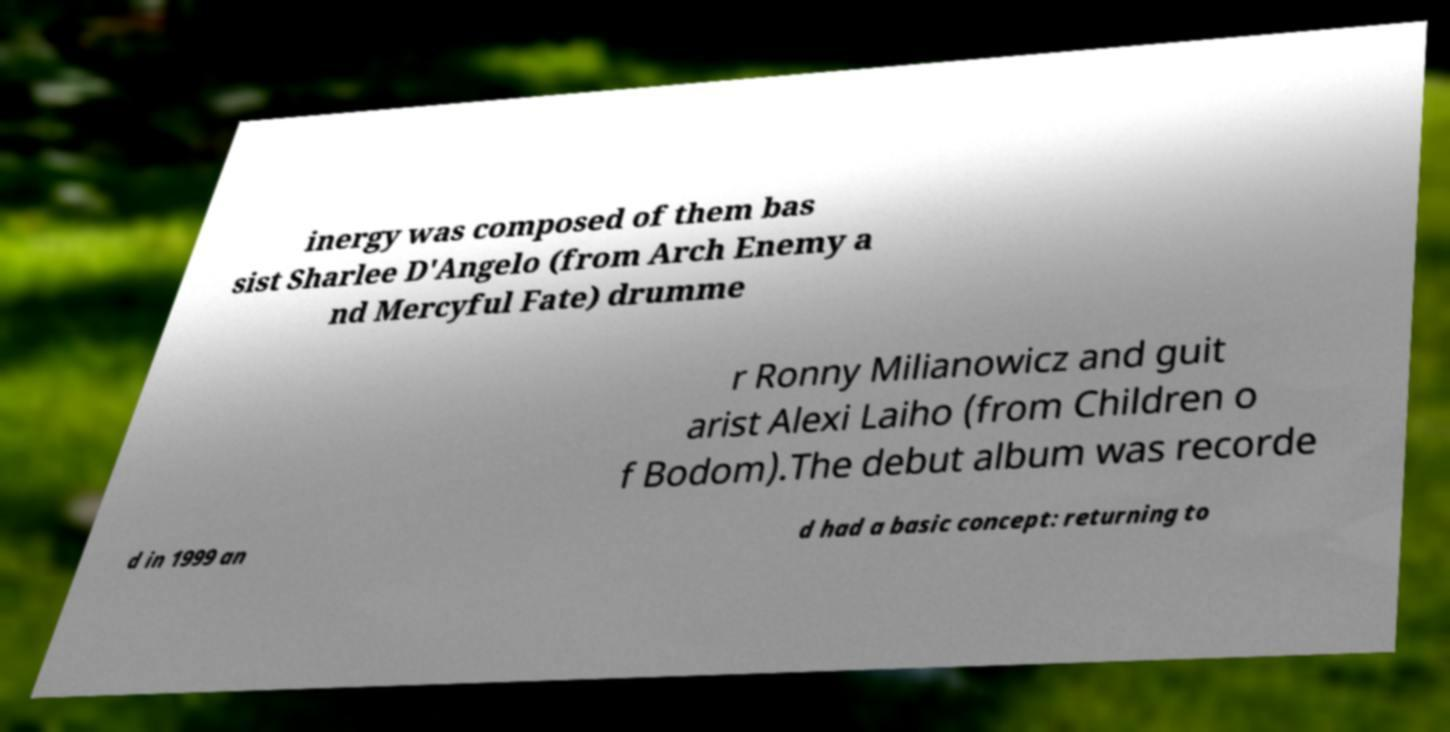I need the written content from this picture converted into text. Can you do that? inergy was composed of them bas sist Sharlee D'Angelo (from Arch Enemy a nd Mercyful Fate) drumme r Ronny Milianowicz and guit arist Alexi Laiho (from Children o f Bodom).The debut album was recorde d in 1999 an d had a basic concept: returning to 